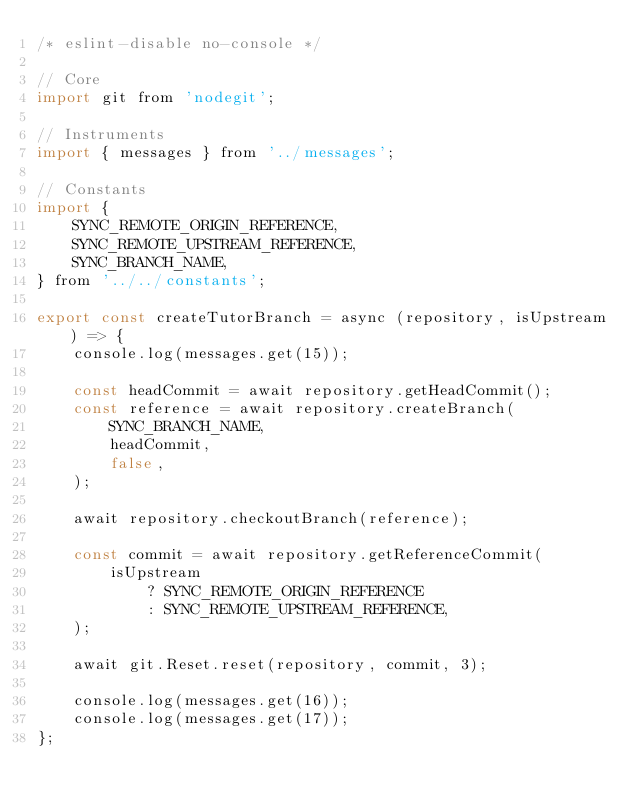Convert code to text. <code><loc_0><loc_0><loc_500><loc_500><_JavaScript_>/* eslint-disable no-console */

// Core
import git from 'nodegit';

// Instruments
import { messages } from '../messages';

// Constants
import {
    SYNC_REMOTE_ORIGIN_REFERENCE,
    SYNC_REMOTE_UPSTREAM_REFERENCE,
    SYNC_BRANCH_NAME,
} from '../../constants';

export const createTutorBranch = async (repository, isUpstream) => {
    console.log(messages.get(15));

    const headCommit = await repository.getHeadCommit();
    const reference = await repository.createBranch(
        SYNC_BRANCH_NAME,
        headCommit,
        false,
    );

    await repository.checkoutBranch(reference);

    const commit = await repository.getReferenceCommit(
        isUpstream
            ? SYNC_REMOTE_ORIGIN_REFERENCE
            : SYNC_REMOTE_UPSTREAM_REFERENCE,
    );

    await git.Reset.reset(repository, commit, 3);

    console.log(messages.get(16));
    console.log(messages.get(17));
};
</code> 